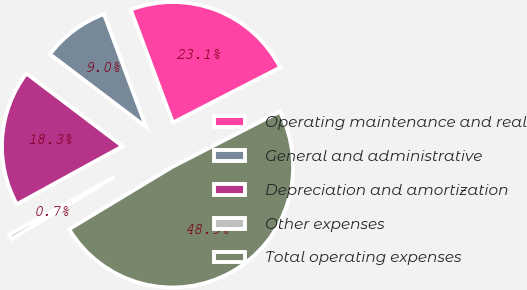Convert chart. <chart><loc_0><loc_0><loc_500><loc_500><pie_chart><fcel>Operating maintenance and real<fcel>General and administrative<fcel>Depreciation and amortization<fcel>Other expenses<fcel>Total operating expenses<nl><fcel>23.13%<fcel>9.0%<fcel>18.3%<fcel>0.66%<fcel>48.91%<nl></chart> 